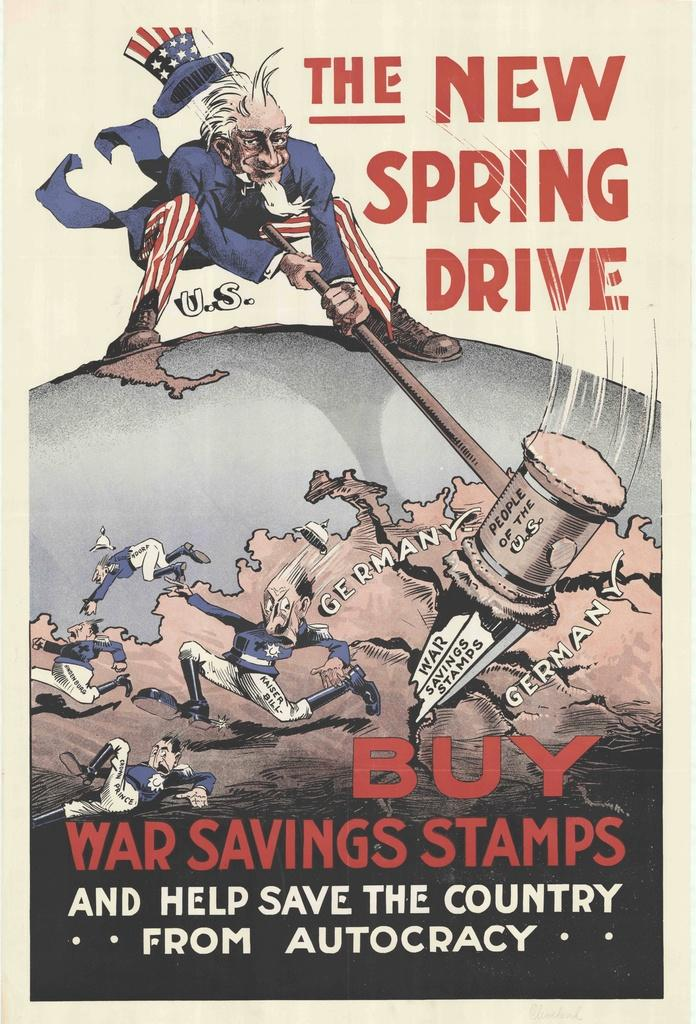<image>
Render a clear and concise summary of the photo. a poster of uncle sam encouraging people to buy war savings stamps and help save the country 